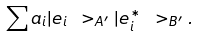<formula> <loc_0><loc_0><loc_500><loc_500>\sum a _ { i } | e _ { i } \ > _ { A ^ { \prime } } | e _ { i } ^ { * } \ > _ { B ^ { \prime } } .</formula> 